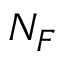Convert formula to latex. <formula><loc_0><loc_0><loc_500><loc_500>N _ { F }</formula> 